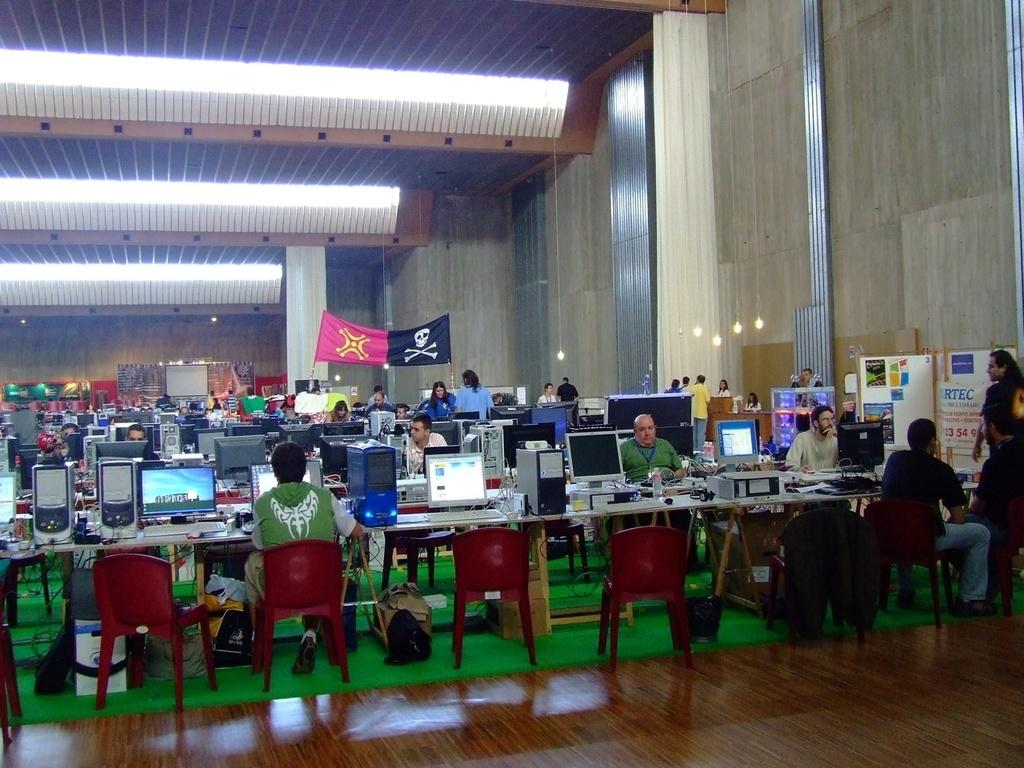How many people are in the image? There is a group of people in the image. What are the people in the image doing? The people are sitting in front of a table. What is on the table in the image? The table has desktops on it. Where is the lunchroom located in the image? There is no reference to a lunchroom in the image. What type of prose is being recited by the people in the image? There is no indication in the image that the people are reciting any prose. 